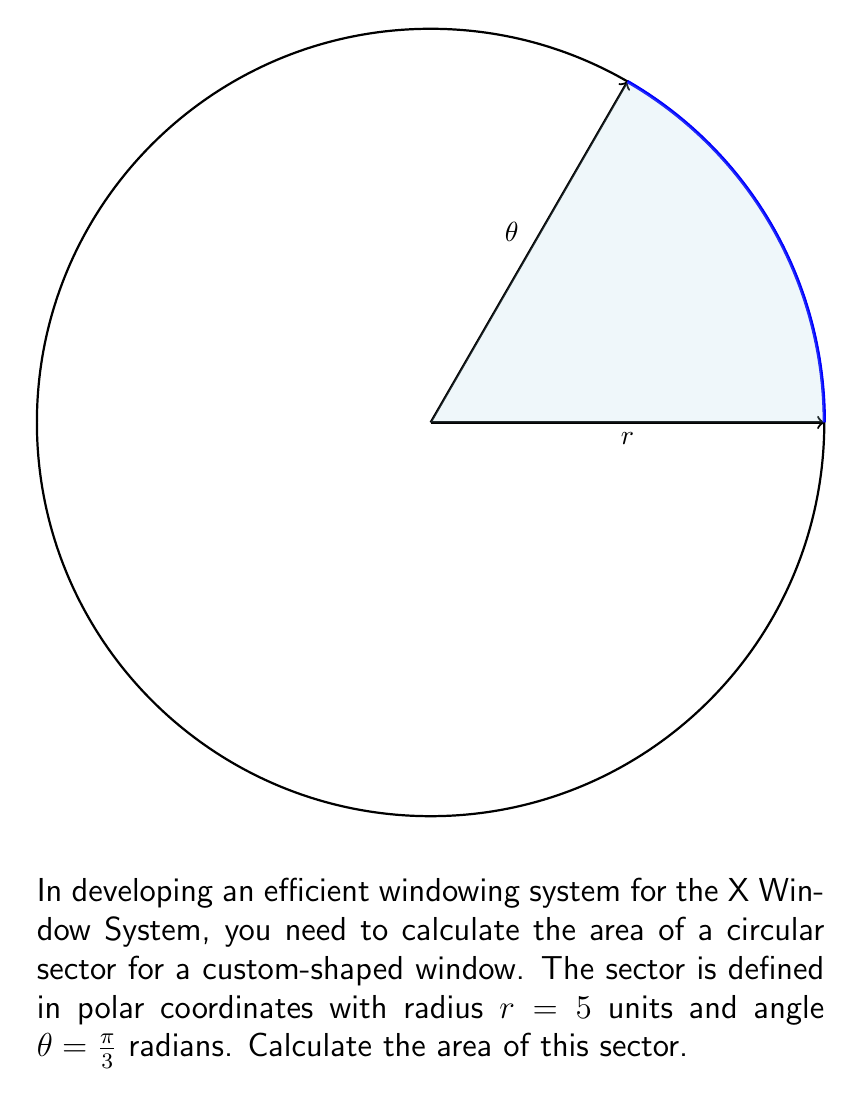Teach me how to tackle this problem. To calculate the area of a sector in polar coordinates, we can use the formula:

$$A = \frac{1}{2}r^2\theta$$

Where:
$A$ is the area of the sector
$r$ is the radius
$\theta$ is the angle in radians

Given:
$r = 5$ units
$\theta = \frac{\pi}{3}$ radians

Let's substitute these values into the formula:

$$\begin{align*}
A &= \frac{1}{2}r^2\theta \\
&= \frac{1}{2} \cdot 5^2 \cdot \frac{\pi}{3} \\
&= \frac{1}{2} \cdot 25 \cdot \frac{\pi}{3} \\
&= \frac{25\pi}{6} \\
&\approx 13.09 \text{ square units}
\end{align*}$$

Therefore, the area of the sector is $\frac{25\pi}{6}$ square units.
Answer: $\frac{25\pi}{6}$ square units 